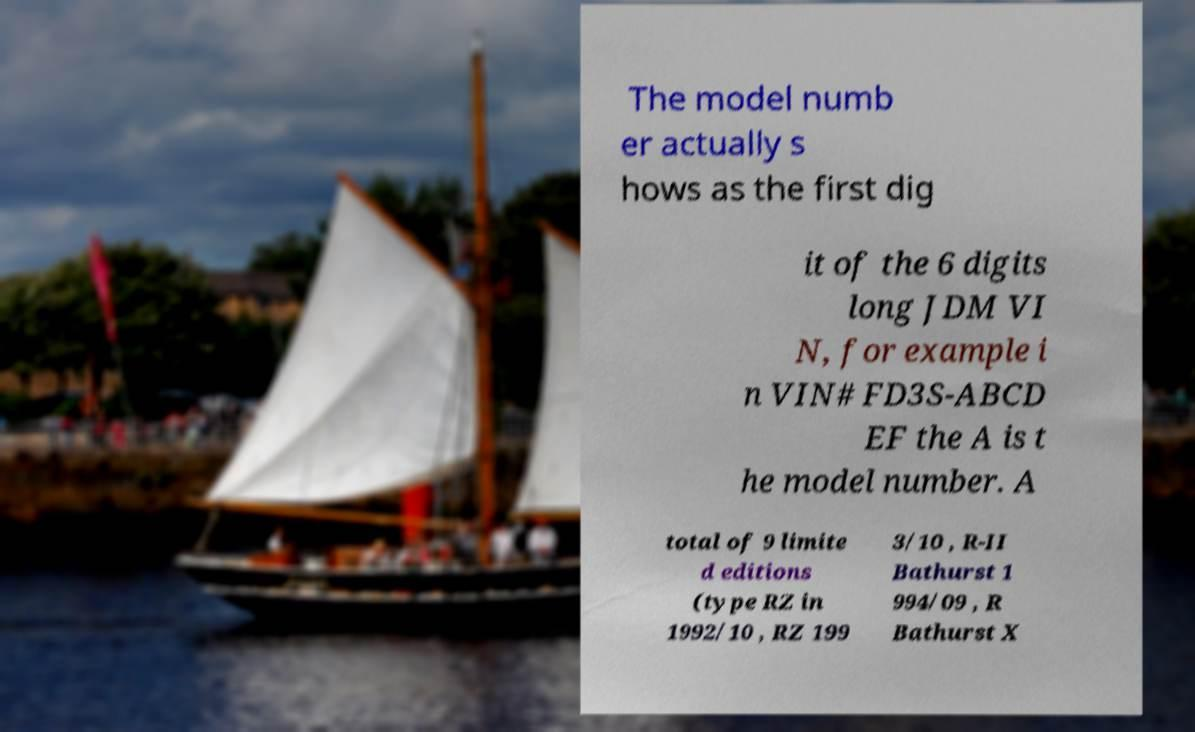Can you accurately transcribe the text from the provided image for me? The model numb er actually s hows as the first dig it of the 6 digits long JDM VI N, for example i n VIN# FD3S-ABCD EF the A is t he model number. A total of 9 limite d editions (type RZ in 1992/10 , RZ 199 3/10 , R-II Bathurst 1 994/09 , R Bathurst X 